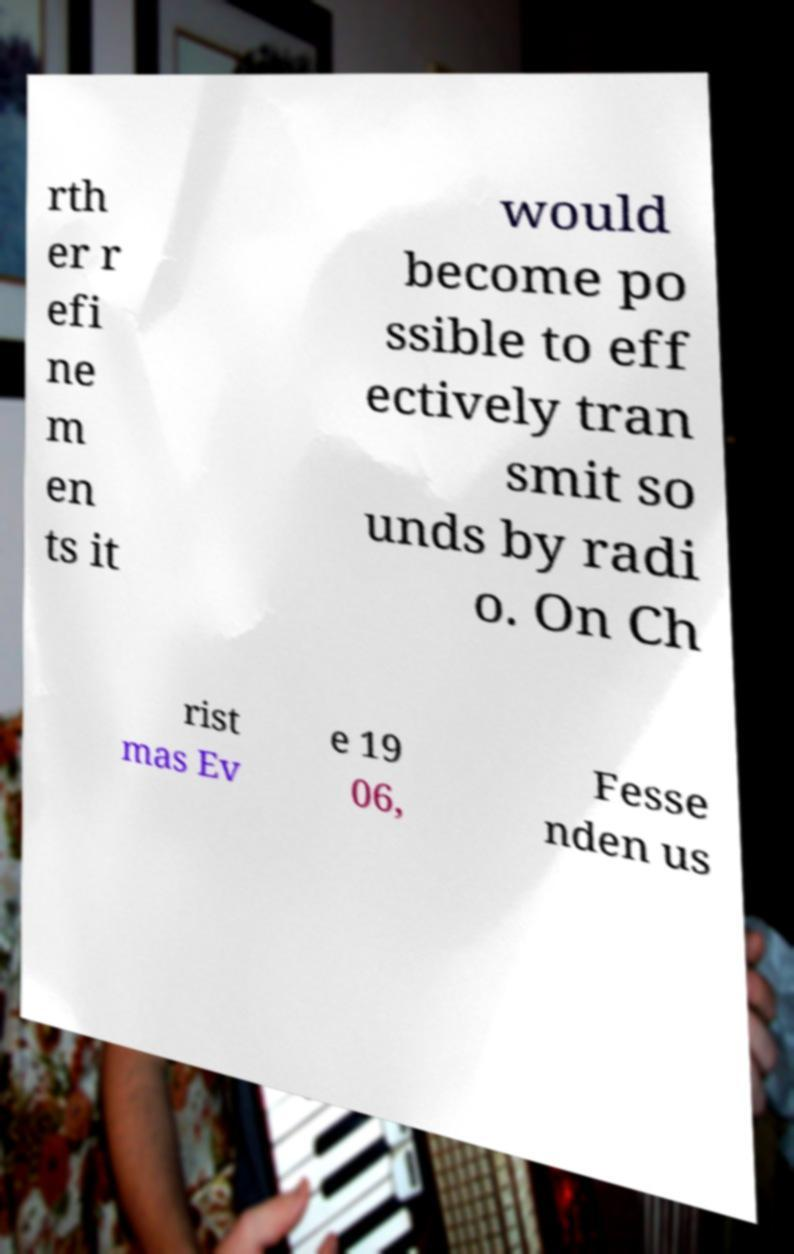I need the written content from this picture converted into text. Can you do that? rth er r efi ne m en ts it would become po ssible to eff ectively tran smit so unds by radi o. On Ch rist mas Ev e 19 06, Fesse nden us 